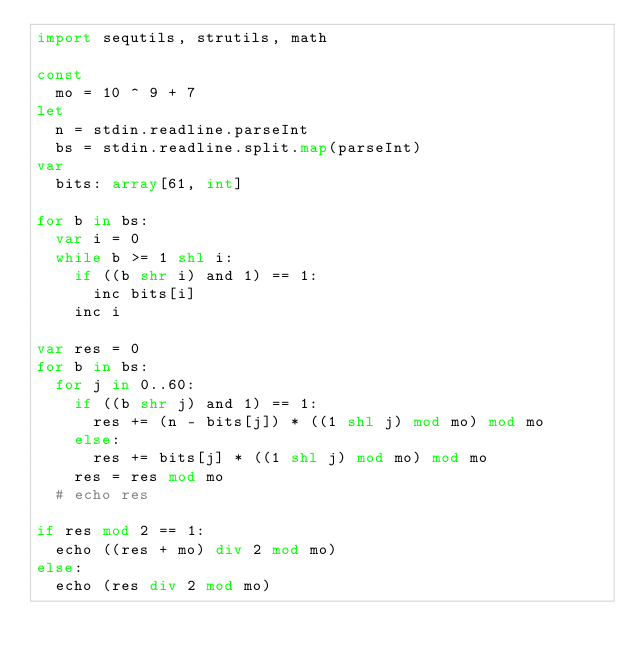<code> <loc_0><loc_0><loc_500><loc_500><_Nim_>import sequtils, strutils, math

const
  mo = 10 ^ 9 + 7
let
  n = stdin.readline.parseInt
  bs = stdin.readline.split.map(parseInt)
var
  bits: array[61, int]

for b in bs:
  var i = 0
  while b >= 1 shl i:
    if ((b shr i) and 1) == 1:
      inc bits[i]
    inc i

var res = 0
for b in bs:
  for j in 0..60:
    if ((b shr j) and 1) == 1:
      res += (n - bits[j]) * ((1 shl j) mod mo) mod mo
    else:
      res += bits[j] * ((1 shl j) mod mo) mod mo
    res = res mod mo
  # echo res

if res mod 2 == 1:
  echo ((res + mo) div 2 mod mo)
else:
  echo (res div 2 mod mo)
</code> 